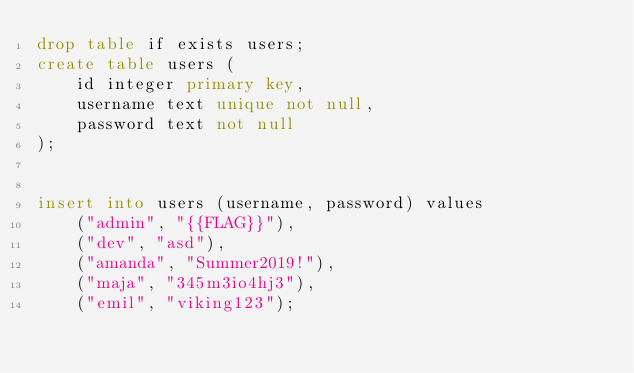<code> <loc_0><loc_0><loc_500><loc_500><_SQL_>drop table if exists users;
create table users (
    id integer primary key,
    username text unique not null,
    password text not null
);


insert into users (username, password) values 
    ("admin", "{{FLAG}}"),
    ("dev", "asd"),
    ("amanda", "Summer2019!"),
    ("maja", "345m3io4hj3"),
    ("emil", "viking123");

</code> 